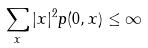<formula> <loc_0><loc_0><loc_500><loc_500>\sum _ { x } | x | ^ { 2 } p ( 0 , x ) \leq \infty</formula> 